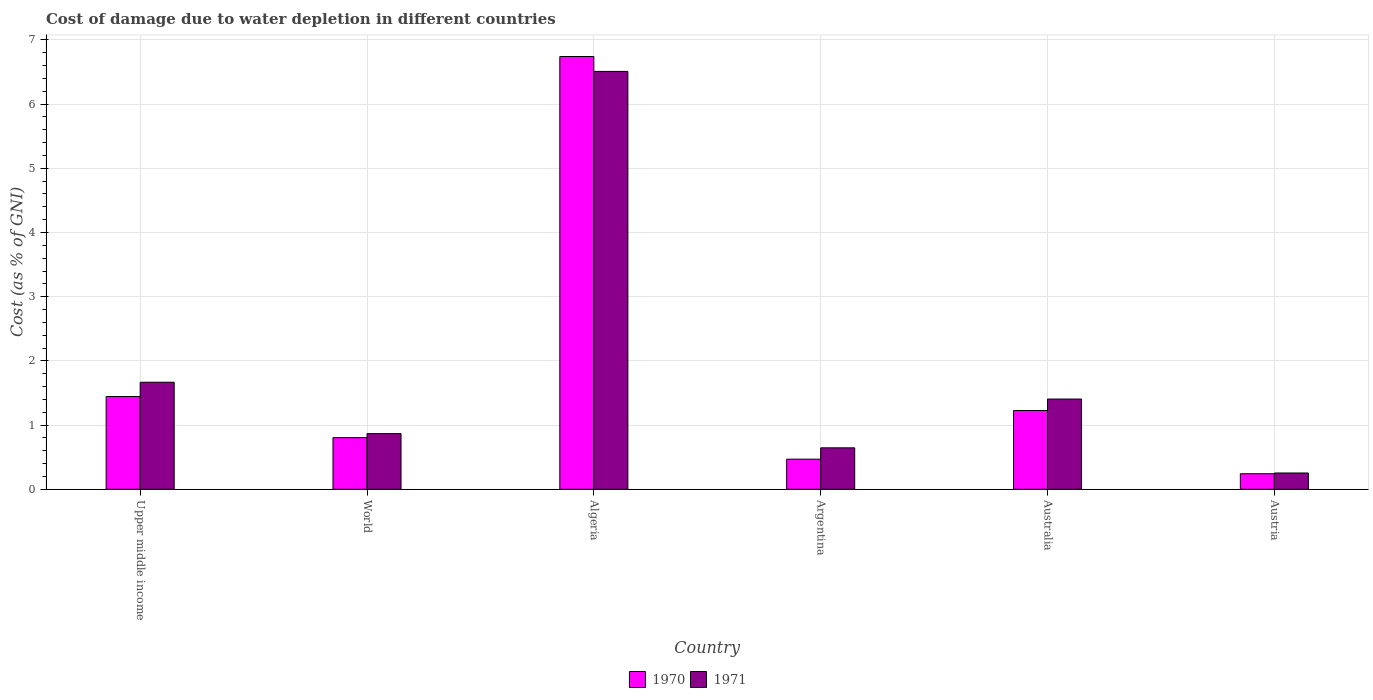How many different coloured bars are there?
Your answer should be very brief. 2. Are the number of bars per tick equal to the number of legend labels?
Ensure brevity in your answer.  Yes. Are the number of bars on each tick of the X-axis equal?
Provide a short and direct response. Yes. What is the label of the 2nd group of bars from the left?
Your answer should be compact. World. What is the cost of damage caused due to water depletion in 1970 in Argentina?
Give a very brief answer. 0.47. Across all countries, what is the maximum cost of damage caused due to water depletion in 1971?
Your answer should be compact. 6.51. Across all countries, what is the minimum cost of damage caused due to water depletion in 1970?
Offer a very short reply. 0.24. In which country was the cost of damage caused due to water depletion in 1971 maximum?
Keep it short and to the point. Algeria. What is the total cost of damage caused due to water depletion in 1971 in the graph?
Provide a short and direct response. 11.35. What is the difference between the cost of damage caused due to water depletion in 1970 in Argentina and that in Upper middle income?
Give a very brief answer. -0.98. What is the difference between the cost of damage caused due to water depletion in 1970 in Argentina and the cost of damage caused due to water depletion in 1971 in World?
Offer a terse response. -0.4. What is the average cost of damage caused due to water depletion in 1971 per country?
Your response must be concise. 1.89. What is the difference between the cost of damage caused due to water depletion of/in 1970 and cost of damage caused due to water depletion of/in 1971 in Australia?
Offer a terse response. -0.18. In how many countries, is the cost of damage caused due to water depletion in 1970 greater than 0.4 %?
Your answer should be very brief. 5. What is the ratio of the cost of damage caused due to water depletion in 1971 in Australia to that in World?
Offer a very short reply. 1.62. Is the difference between the cost of damage caused due to water depletion in 1970 in Australia and Austria greater than the difference between the cost of damage caused due to water depletion in 1971 in Australia and Austria?
Your answer should be compact. No. What is the difference between the highest and the second highest cost of damage caused due to water depletion in 1971?
Your response must be concise. -4.84. What is the difference between the highest and the lowest cost of damage caused due to water depletion in 1971?
Make the answer very short. 6.26. Is the sum of the cost of damage caused due to water depletion in 1970 in Algeria and Upper middle income greater than the maximum cost of damage caused due to water depletion in 1971 across all countries?
Keep it short and to the point. Yes. What does the 2nd bar from the left in Upper middle income represents?
Offer a terse response. 1971. How many bars are there?
Offer a terse response. 12. What is the difference between two consecutive major ticks on the Y-axis?
Keep it short and to the point. 1. How many legend labels are there?
Keep it short and to the point. 2. What is the title of the graph?
Your answer should be compact. Cost of damage due to water depletion in different countries. Does "1961" appear as one of the legend labels in the graph?
Provide a short and direct response. No. What is the label or title of the X-axis?
Give a very brief answer. Country. What is the label or title of the Y-axis?
Keep it short and to the point. Cost (as % of GNI). What is the Cost (as % of GNI) in 1970 in Upper middle income?
Offer a terse response. 1.44. What is the Cost (as % of GNI) in 1971 in Upper middle income?
Offer a very short reply. 1.67. What is the Cost (as % of GNI) of 1970 in World?
Offer a very short reply. 0.8. What is the Cost (as % of GNI) in 1971 in World?
Give a very brief answer. 0.87. What is the Cost (as % of GNI) of 1970 in Algeria?
Offer a terse response. 6.74. What is the Cost (as % of GNI) of 1971 in Algeria?
Offer a very short reply. 6.51. What is the Cost (as % of GNI) of 1970 in Argentina?
Your response must be concise. 0.47. What is the Cost (as % of GNI) of 1971 in Argentina?
Ensure brevity in your answer.  0.65. What is the Cost (as % of GNI) in 1970 in Australia?
Give a very brief answer. 1.23. What is the Cost (as % of GNI) in 1971 in Australia?
Your answer should be compact. 1.41. What is the Cost (as % of GNI) in 1970 in Austria?
Ensure brevity in your answer.  0.24. What is the Cost (as % of GNI) in 1971 in Austria?
Make the answer very short. 0.25. Across all countries, what is the maximum Cost (as % of GNI) in 1970?
Make the answer very short. 6.74. Across all countries, what is the maximum Cost (as % of GNI) of 1971?
Make the answer very short. 6.51. Across all countries, what is the minimum Cost (as % of GNI) in 1970?
Give a very brief answer. 0.24. Across all countries, what is the minimum Cost (as % of GNI) in 1971?
Keep it short and to the point. 0.25. What is the total Cost (as % of GNI) of 1970 in the graph?
Your answer should be compact. 10.93. What is the total Cost (as % of GNI) of 1971 in the graph?
Offer a very short reply. 11.35. What is the difference between the Cost (as % of GNI) in 1970 in Upper middle income and that in World?
Ensure brevity in your answer.  0.64. What is the difference between the Cost (as % of GNI) in 1971 in Upper middle income and that in World?
Ensure brevity in your answer.  0.8. What is the difference between the Cost (as % of GNI) of 1970 in Upper middle income and that in Algeria?
Your answer should be compact. -5.3. What is the difference between the Cost (as % of GNI) in 1971 in Upper middle income and that in Algeria?
Ensure brevity in your answer.  -4.84. What is the difference between the Cost (as % of GNI) of 1970 in Upper middle income and that in Argentina?
Provide a succinct answer. 0.98. What is the difference between the Cost (as % of GNI) of 1971 in Upper middle income and that in Argentina?
Your response must be concise. 1.02. What is the difference between the Cost (as % of GNI) in 1970 in Upper middle income and that in Australia?
Give a very brief answer. 0.22. What is the difference between the Cost (as % of GNI) in 1971 in Upper middle income and that in Australia?
Offer a very short reply. 0.26. What is the difference between the Cost (as % of GNI) in 1970 in Upper middle income and that in Austria?
Make the answer very short. 1.2. What is the difference between the Cost (as % of GNI) of 1971 in Upper middle income and that in Austria?
Your answer should be compact. 1.41. What is the difference between the Cost (as % of GNI) of 1970 in World and that in Algeria?
Ensure brevity in your answer.  -5.94. What is the difference between the Cost (as % of GNI) of 1971 in World and that in Algeria?
Your answer should be very brief. -5.64. What is the difference between the Cost (as % of GNI) of 1970 in World and that in Argentina?
Your answer should be very brief. 0.34. What is the difference between the Cost (as % of GNI) in 1971 in World and that in Argentina?
Your answer should be very brief. 0.22. What is the difference between the Cost (as % of GNI) in 1970 in World and that in Australia?
Provide a short and direct response. -0.42. What is the difference between the Cost (as % of GNI) of 1971 in World and that in Australia?
Keep it short and to the point. -0.54. What is the difference between the Cost (as % of GNI) in 1970 in World and that in Austria?
Offer a very short reply. 0.56. What is the difference between the Cost (as % of GNI) in 1971 in World and that in Austria?
Your response must be concise. 0.61. What is the difference between the Cost (as % of GNI) in 1970 in Algeria and that in Argentina?
Your answer should be very brief. 6.27. What is the difference between the Cost (as % of GNI) in 1971 in Algeria and that in Argentina?
Ensure brevity in your answer.  5.86. What is the difference between the Cost (as % of GNI) of 1970 in Algeria and that in Australia?
Offer a very short reply. 5.52. What is the difference between the Cost (as % of GNI) in 1971 in Algeria and that in Australia?
Your answer should be very brief. 5.1. What is the difference between the Cost (as % of GNI) of 1970 in Algeria and that in Austria?
Keep it short and to the point. 6.5. What is the difference between the Cost (as % of GNI) in 1971 in Algeria and that in Austria?
Provide a short and direct response. 6.26. What is the difference between the Cost (as % of GNI) in 1970 in Argentina and that in Australia?
Provide a short and direct response. -0.76. What is the difference between the Cost (as % of GNI) of 1971 in Argentina and that in Australia?
Provide a short and direct response. -0.76. What is the difference between the Cost (as % of GNI) of 1970 in Argentina and that in Austria?
Ensure brevity in your answer.  0.23. What is the difference between the Cost (as % of GNI) in 1971 in Argentina and that in Austria?
Make the answer very short. 0.39. What is the difference between the Cost (as % of GNI) of 1970 in Australia and that in Austria?
Give a very brief answer. 0.98. What is the difference between the Cost (as % of GNI) of 1971 in Australia and that in Austria?
Make the answer very short. 1.15. What is the difference between the Cost (as % of GNI) of 1970 in Upper middle income and the Cost (as % of GNI) of 1971 in World?
Ensure brevity in your answer.  0.58. What is the difference between the Cost (as % of GNI) in 1970 in Upper middle income and the Cost (as % of GNI) in 1971 in Algeria?
Provide a succinct answer. -5.07. What is the difference between the Cost (as % of GNI) of 1970 in Upper middle income and the Cost (as % of GNI) of 1971 in Argentina?
Ensure brevity in your answer.  0.8. What is the difference between the Cost (as % of GNI) in 1970 in Upper middle income and the Cost (as % of GNI) in 1971 in Australia?
Your answer should be compact. 0.04. What is the difference between the Cost (as % of GNI) of 1970 in Upper middle income and the Cost (as % of GNI) of 1971 in Austria?
Keep it short and to the point. 1.19. What is the difference between the Cost (as % of GNI) of 1970 in World and the Cost (as % of GNI) of 1971 in Algeria?
Your answer should be very brief. -5.71. What is the difference between the Cost (as % of GNI) of 1970 in World and the Cost (as % of GNI) of 1971 in Argentina?
Ensure brevity in your answer.  0.16. What is the difference between the Cost (as % of GNI) in 1970 in World and the Cost (as % of GNI) in 1971 in Australia?
Give a very brief answer. -0.6. What is the difference between the Cost (as % of GNI) in 1970 in World and the Cost (as % of GNI) in 1971 in Austria?
Give a very brief answer. 0.55. What is the difference between the Cost (as % of GNI) of 1970 in Algeria and the Cost (as % of GNI) of 1971 in Argentina?
Make the answer very short. 6.1. What is the difference between the Cost (as % of GNI) in 1970 in Algeria and the Cost (as % of GNI) in 1971 in Australia?
Your answer should be compact. 5.34. What is the difference between the Cost (as % of GNI) of 1970 in Algeria and the Cost (as % of GNI) of 1971 in Austria?
Ensure brevity in your answer.  6.49. What is the difference between the Cost (as % of GNI) in 1970 in Argentina and the Cost (as % of GNI) in 1971 in Australia?
Offer a very short reply. -0.94. What is the difference between the Cost (as % of GNI) of 1970 in Argentina and the Cost (as % of GNI) of 1971 in Austria?
Your answer should be compact. 0.22. What is the difference between the Cost (as % of GNI) of 1970 in Australia and the Cost (as % of GNI) of 1971 in Austria?
Your response must be concise. 0.97. What is the average Cost (as % of GNI) of 1970 per country?
Offer a terse response. 1.82. What is the average Cost (as % of GNI) in 1971 per country?
Offer a terse response. 1.89. What is the difference between the Cost (as % of GNI) in 1970 and Cost (as % of GNI) in 1971 in Upper middle income?
Make the answer very short. -0.22. What is the difference between the Cost (as % of GNI) in 1970 and Cost (as % of GNI) in 1971 in World?
Your response must be concise. -0.06. What is the difference between the Cost (as % of GNI) of 1970 and Cost (as % of GNI) of 1971 in Algeria?
Your answer should be compact. 0.23. What is the difference between the Cost (as % of GNI) in 1970 and Cost (as % of GNI) in 1971 in Argentina?
Provide a succinct answer. -0.18. What is the difference between the Cost (as % of GNI) in 1970 and Cost (as % of GNI) in 1971 in Australia?
Provide a short and direct response. -0.18. What is the difference between the Cost (as % of GNI) of 1970 and Cost (as % of GNI) of 1971 in Austria?
Your answer should be compact. -0.01. What is the ratio of the Cost (as % of GNI) of 1970 in Upper middle income to that in World?
Make the answer very short. 1.8. What is the ratio of the Cost (as % of GNI) in 1971 in Upper middle income to that in World?
Your answer should be very brief. 1.92. What is the ratio of the Cost (as % of GNI) in 1970 in Upper middle income to that in Algeria?
Offer a terse response. 0.21. What is the ratio of the Cost (as % of GNI) of 1971 in Upper middle income to that in Algeria?
Ensure brevity in your answer.  0.26. What is the ratio of the Cost (as % of GNI) in 1970 in Upper middle income to that in Argentina?
Provide a short and direct response. 3.08. What is the ratio of the Cost (as % of GNI) of 1971 in Upper middle income to that in Argentina?
Keep it short and to the point. 2.58. What is the ratio of the Cost (as % of GNI) in 1970 in Upper middle income to that in Australia?
Make the answer very short. 1.18. What is the ratio of the Cost (as % of GNI) of 1971 in Upper middle income to that in Australia?
Offer a very short reply. 1.19. What is the ratio of the Cost (as % of GNI) of 1970 in Upper middle income to that in Austria?
Your answer should be compact. 5.97. What is the ratio of the Cost (as % of GNI) of 1971 in Upper middle income to that in Austria?
Your response must be concise. 6.57. What is the ratio of the Cost (as % of GNI) of 1970 in World to that in Algeria?
Offer a terse response. 0.12. What is the ratio of the Cost (as % of GNI) in 1971 in World to that in Algeria?
Ensure brevity in your answer.  0.13. What is the ratio of the Cost (as % of GNI) of 1970 in World to that in Argentina?
Provide a succinct answer. 1.72. What is the ratio of the Cost (as % of GNI) in 1971 in World to that in Argentina?
Give a very brief answer. 1.34. What is the ratio of the Cost (as % of GNI) in 1970 in World to that in Australia?
Your answer should be compact. 0.66. What is the ratio of the Cost (as % of GNI) of 1971 in World to that in Australia?
Ensure brevity in your answer.  0.62. What is the ratio of the Cost (as % of GNI) of 1970 in World to that in Austria?
Offer a terse response. 3.32. What is the ratio of the Cost (as % of GNI) in 1971 in World to that in Austria?
Provide a short and direct response. 3.42. What is the ratio of the Cost (as % of GNI) of 1970 in Algeria to that in Argentina?
Give a very brief answer. 14.38. What is the ratio of the Cost (as % of GNI) of 1971 in Algeria to that in Argentina?
Keep it short and to the point. 10.08. What is the ratio of the Cost (as % of GNI) in 1970 in Algeria to that in Australia?
Your answer should be very brief. 5.5. What is the ratio of the Cost (as % of GNI) in 1971 in Algeria to that in Australia?
Keep it short and to the point. 4.63. What is the ratio of the Cost (as % of GNI) of 1970 in Algeria to that in Austria?
Provide a succinct answer. 27.86. What is the ratio of the Cost (as % of GNI) of 1971 in Algeria to that in Austria?
Your response must be concise. 25.65. What is the ratio of the Cost (as % of GNI) of 1970 in Argentina to that in Australia?
Ensure brevity in your answer.  0.38. What is the ratio of the Cost (as % of GNI) of 1971 in Argentina to that in Australia?
Provide a succinct answer. 0.46. What is the ratio of the Cost (as % of GNI) in 1970 in Argentina to that in Austria?
Ensure brevity in your answer.  1.94. What is the ratio of the Cost (as % of GNI) of 1971 in Argentina to that in Austria?
Make the answer very short. 2.54. What is the ratio of the Cost (as % of GNI) in 1970 in Australia to that in Austria?
Provide a succinct answer. 5.07. What is the ratio of the Cost (as % of GNI) in 1971 in Australia to that in Austria?
Make the answer very short. 5.54. What is the difference between the highest and the second highest Cost (as % of GNI) in 1970?
Offer a terse response. 5.3. What is the difference between the highest and the second highest Cost (as % of GNI) of 1971?
Make the answer very short. 4.84. What is the difference between the highest and the lowest Cost (as % of GNI) of 1970?
Provide a short and direct response. 6.5. What is the difference between the highest and the lowest Cost (as % of GNI) in 1971?
Make the answer very short. 6.26. 